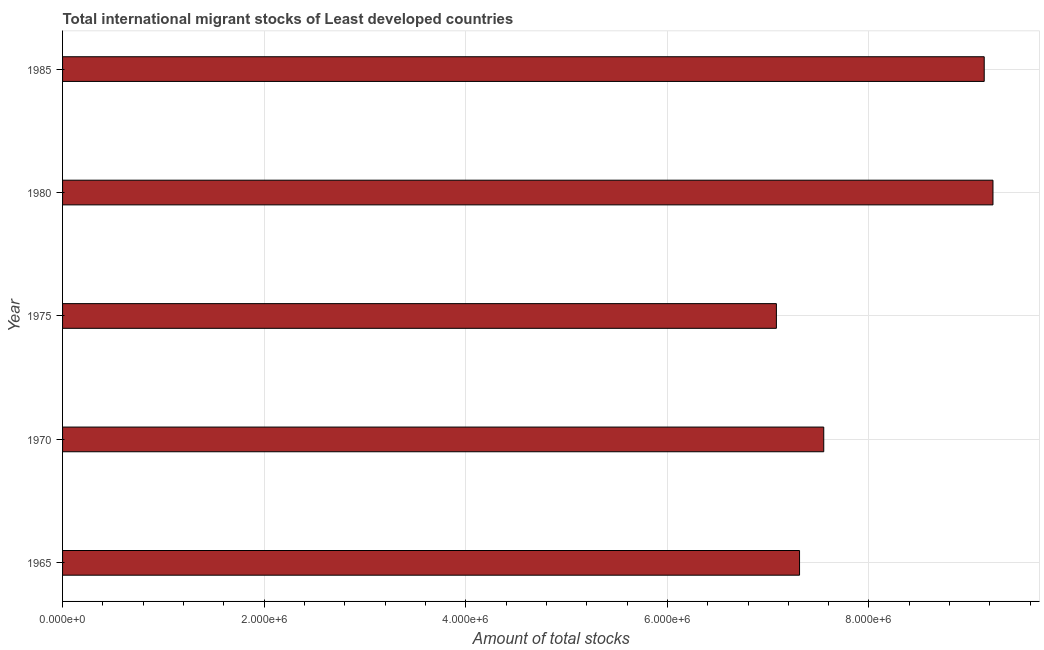Does the graph contain grids?
Your answer should be very brief. Yes. What is the title of the graph?
Keep it short and to the point. Total international migrant stocks of Least developed countries. What is the label or title of the X-axis?
Offer a terse response. Amount of total stocks. What is the total number of international migrant stock in 1965?
Provide a succinct answer. 7.31e+06. Across all years, what is the maximum total number of international migrant stock?
Your answer should be very brief. 9.23e+06. Across all years, what is the minimum total number of international migrant stock?
Offer a terse response. 7.08e+06. In which year was the total number of international migrant stock maximum?
Provide a succinct answer. 1980. In which year was the total number of international migrant stock minimum?
Your response must be concise. 1975. What is the sum of the total number of international migrant stock?
Your answer should be very brief. 4.03e+07. What is the difference between the total number of international migrant stock in 1975 and 1985?
Your response must be concise. -2.06e+06. What is the average total number of international migrant stock per year?
Give a very brief answer. 8.06e+06. What is the median total number of international migrant stock?
Provide a short and direct response. 7.55e+06. What is the ratio of the total number of international migrant stock in 1970 to that in 1975?
Offer a terse response. 1.07. Is the total number of international migrant stock in 1965 less than that in 1980?
Your answer should be very brief. Yes. What is the difference between the highest and the second highest total number of international migrant stock?
Ensure brevity in your answer.  8.69e+04. Is the sum of the total number of international migrant stock in 1975 and 1980 greater than the maximum total number of international migrant stock across all years?
Make the answer very short. Yes. What is the difference between the highest and the lowest total number of international migrant stock?
Ensure brevity in your answer.  2.15e+06. Are all the bars in the graph horizontal?
Offer a very short reply. Yes. Are the values on the major ticks of X-axis written in scientific E-notation?
Offer a very short reply. Yes. What is the Amount of total stocks in 1965?
Make the answer very short. 7.31e+06. What is the Amount of total stocks of 1970?
Ensure brevity in your answer.  7.55e+06. What is the Amount of total stocks of 1975?
Ensure brevity in your answer.  7.08e+06. What is the Amount of total stocks in 1980?
Offer a terse response. 9.23e+06. What is the Amount of total stocks in 1985?
Give a very brief answer. 9.14e+06. What is the difference between the Amount of total stocks in 1965 and 1970?
Your response must be concise. -2.40e+05. What is the difference between the Amount of total stocks in 1965 and 1975?
Your answer should be compact. 2.30e+05. What is the difference between the Amount of total stocks in 1965 and 1980?
Give a very brief answer. -1.92e+06. What is the difference between the Amount of total stocks in 1965 and 1985?
Your response must be concise. -1.83e+06. What is the difference between the Amount of total stocks in 1970 and 1975?
Keep it short and to the point. 4.70e+05. What is the difference between the Amount of total stocks in 1970 and 1980?
Your answer should be very brief. -1.68e+06. What is the difference between the Amount of total stocks in 1970 and 1985?
Your answer should be compact. -1.59e+06. What is the difference between the Amount of total stocks in 1975 and 1980?
Your answer should be compact. -2.15e+06. What is the difference between the Amount of total stocks in 1975 and 1985?
Ensure brevity in your answer.  -2.06e+06. What is the difference between the Amount of total stocks in 1980 and 1985?
Provide a succinct answer. 8.69e+04. What is the ratio of the Amount of total stocks in 1965 to that in 1975?
Offer a terse response. 1.03. What is the ratio of the Amount of total stocks in 1965 to that in 1980?
Provide a succinct answer. 0.79. What is the ratio of the Amount of total stocks in 1970 to that in 1975?
Keep it short and to the point. 1.07. What is the ratio of the Amount of total stocks in 1970 to that in 1980?
Your answer should be very brief. 0.82. What is the ratio of the Amount of total stocks in 1970 to that in 1985?
Keep it short and to the point. 0.83. What is the ratio of the Amount of total stocks in 1975 to that in 1980?
Your answer should be compact. 0.77. What is the ratio of the Amount of total stocks in 1975 to that in 1985?
Your response must be concise. 0.78. What is the ratio of the Amount of total stocks in 1980 to that in 1985?
Give a very brief answer. 1.01. 